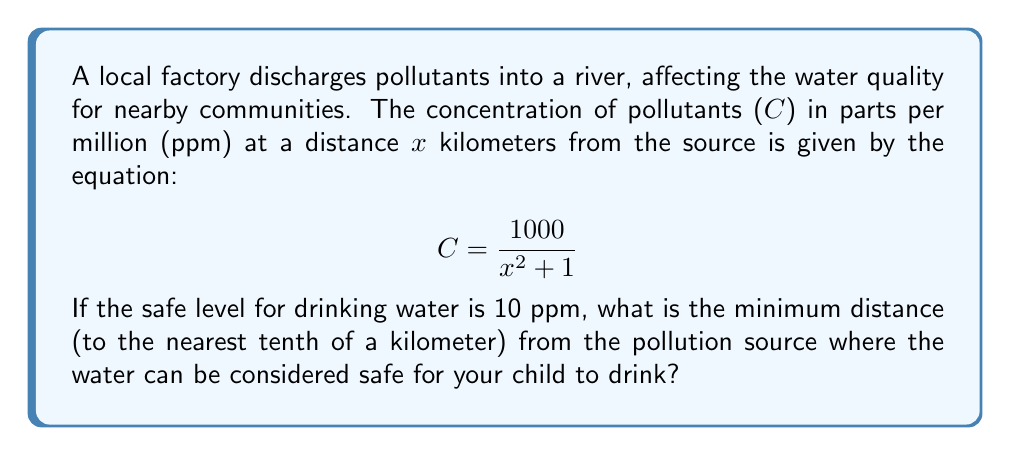Can you answer this question? 1. We need to find the value of x where C = 10 ppm (the safe level).

2. Substitute C with 10 in the equation:
   $$ 10 = \frac{1000}{x^2 + 1} $$

3. Multiply both sides by $(x^2 + 1)$:
   $$ 10(x^2 + 1) = 1000 $$

4. Expand the left side:
   $$ 10x^2 + 10 = 1000 $$

5. Subtract 10 from both sides:
   $$ 10x^2 = 990 $$

6. Divide both sides by 10:
   $$ x^2 = 99 $$

7. Take the square root of both sides:
   $$ x = \sqrt{99} $$

8. Calculate the value of x:
   $$ x \approx 9.9498 $$

9. Round to the nearest tenth:
   $$ x \approx 9.9 \text{ km} $$
Answer: 9.9 km 